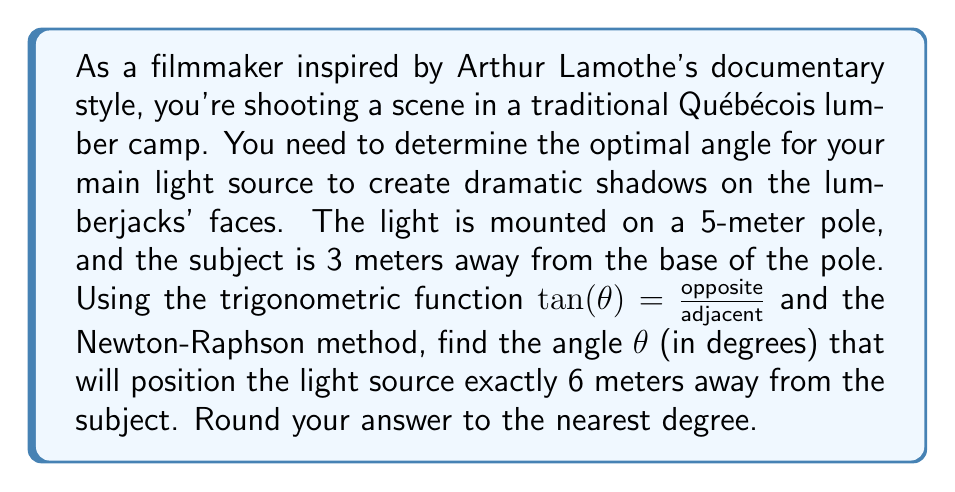Provide a solution to this math problem. Let's approach this step-by-step:

1) First, we need to set up our equation. We can use the Pythagorean theorem:

   $$6^2 = 3^2 + (5 - x)^2$$

   where $x$ is the height at which the light hits the subject.

2) We can express $x$ in terms of $\theta$:

   $x = 3 \tan(\theta)$

3) Substituting this into our equation:

   $$6^2 = 3^2 + (5 - 3\tan(\theta))^2$$

4) Simplifying:

   $$36 = 9 + 25 - 30\tan(\theta) + 9\tan^2(\theta)$$

5) Rearranging to get our function $f(\theta)$:

   $$f(\theta) = 9\tan^2(\theta) - 30\tan(\theta) - 2 = 0$$

6) To use the Newton-Raphson method, we also need the derivative:

   $$f'(\theta) = 18\tan(\theta)\sec^2(\theta) - 30\sec^2(\theta)$$

7) The Newton-Raphson formula is:

   $$\theta_{n+1} = \theta_n - \frac{f(\theta_n)}{f'(\theta_n)}$$

8) Let's start with an initial guess of $\theta_0 = 45°$ (or $\pi/4$ radians):

   $$\theta_1 = \frac{\pi}{4} - \frac{9\tan^2(\frac{\pi}{4}) - 30\tan(\frac{\pi}{4}) - 2}{18\tan(\frac{\pi}{4})\sec^2(\frac{\pi}{4}) - 30\sec^2(\frac{\pi}{4})} \approx 0.78$$

9) Continuing this process for a few more iterations:

   $\theta_2 \approx 0.7648$
   $\theta_3 \approx 0.7647$

10) Converting to degrees:

    $0.7647 \text{ radians} \times \frac{180°}{\pi} \approx 43.8°$

11) Rounding to the nearest degree:

    $43.8° \approx 44°$
Answer: 44° 